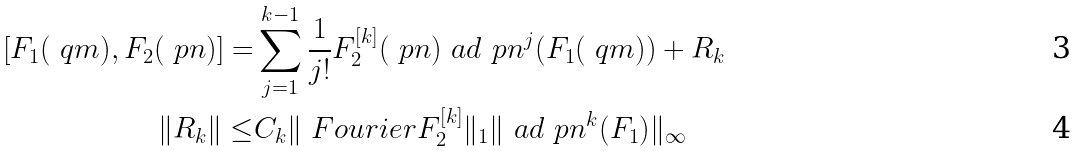Convert formula to latex. <formula><loc_0><loc_0><loc_500><loc_500>[ F _ { 1 } ( \ q m ) , F _ { 2 } ( \ p n ) ] = & \sum _ { j = 1 } ^ { k - 1 } \frac { 1 } { j ! } F _ { 2 } ^ { [ k ] } ( \ p n ) \ a d _ { \ } p n ^ { j } ( F _ { 1 } ( \ q m ) ) + R _ { k } \\ \| R _ { k } \| \leq & C _ { k } \| \ F o u r i e r { F _ { 2 } ^ { [ k ] } } \| _ { 1 } \| \ a d _ { \ } p n ^ { k } ( F _ { 1 } ) \| _ { \infty }</formula> 